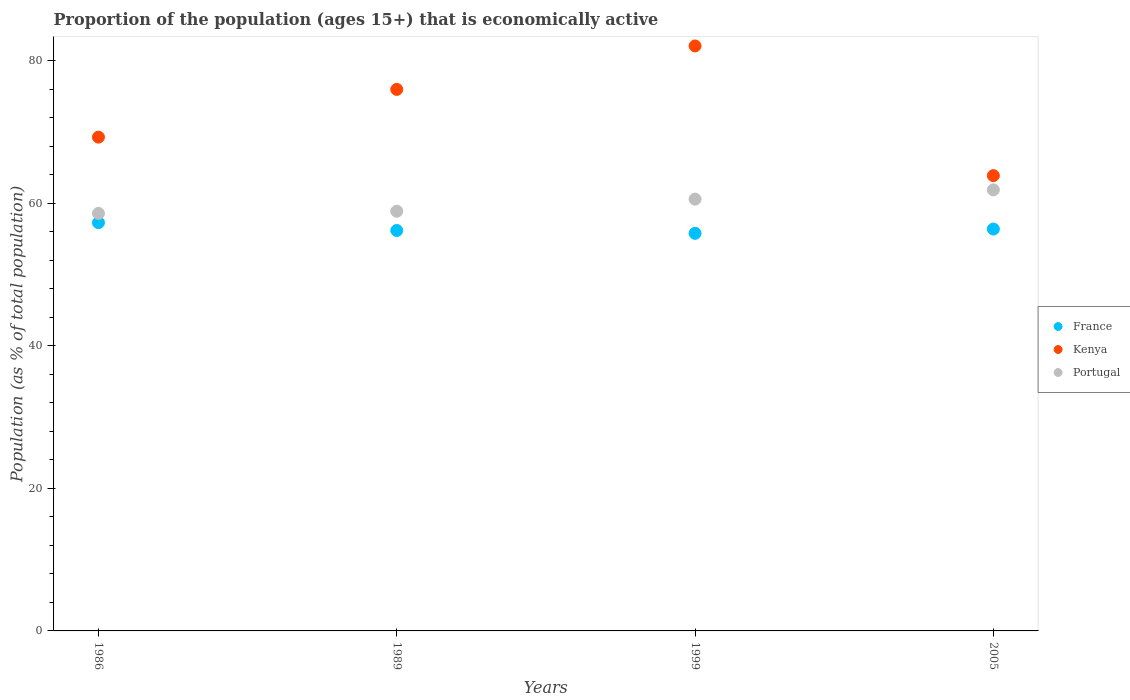Is the number of dotlines equal to the number of legend labels?
Make the answer very short. Yes. What is the proportion of the population that is economically active in Portugal in 1989?
Provide a succinct answer. 58.9. Across all years, what is the maximum proportion of the population that is economically active in Kenya?
Your response must be concise. 82.1. Across all years, what is the minimum proportion of the population that is economically active in France?
Make the answer very short. 55.8. In which year was the proportion of the population that is economically active in Kenya minimum?
Give a very brief answer. 2005. What is the total proportion of the population that is economically active in Portugal in the graph?
Keep it short and to the point. 240. What is the difference between the proportion of the population that is economically active in Kenya in 1986 and that in 2005?
Provide a short and direct response. 5.4. What is the difference between the proportion of the population that is economically active in Kenya in 1989 and the proportion of the population that is economically active in Portugal in 1986?
Provide a short and direct response. 17.4. What is the average proportion of the population that is economically active in France per year?
Offer a terse response. 56.43. In the year 1989, what is the difference between the proportion of the population that is economically active in Portugal and proportion of the population that is economically active in Kenya?
Offer a very short reply. -17.1. What is the ratio of the proportion of the population that is economically active in Portugal in 1989 to that in 2005?
Offer a very short reply. 0.95. Is the difference between the proportion of the population that is economically active in Portugal in 1989 and 1999 greater than the difference between the proportion of the population that is economically active in Kenya in 1989 and 1999?
Your answer should be compact. Yes. What is the difference between the highest and the second highest proportion of the population that is economically active in Kenya?
Provide a short and direct response. 6.1. What is the difference between the highest and the lowest proportion of the population that is economically active in France?
Provide a succinct answer. 1.5. In how many years, is the proportion of the population that is economically active in Portugal greater than the average proportion of the population that is economically active in Portugal taken over all years?
Make the answer very short. 2. Is it the case that in every year, the sum of the proportion of the population that is economically active in France and proportion of the population that is economically active in Portugal  is greater than the proportion of the population that is economically active in Kenya?
Your answer should be compact. Yes. Does the proportion of the population that is economically active in Kenya monotonically increase over the years?
Offer a very short reply. No. Is the proportion of the population that is economically active in Kenya strictly less than the proportion of the population that is economically active in France over the years?
Provide a short and direct response. No. How many dotlines are there?
Give a very brief answer. 3. What is the difference between two consecutive major ticks on the Y-axis?
Keep it short and to the point. 20. Does the graph contain grids?
Your response must be concise. No. What is the title of the graph?
Offer a very short reply. Proportion of the population (ages 15+) that is economically active. What is the label or title of the X-axis?
Your answer should be compact. Years. What is the label or title of the Y-axis?
Your response must be concise. Population (as % of total population). What is the Population (as % of total population) in France in 1986?
Ensure brevity in your answer.  57.3. What is the Population (as % of total population) of Kenya in 1986?
Offer a very short reply. 69.3. What is the Population (as % of total population) in Portugal in 1986?
Your response must be concise. 58.6. What is the Population (as % of total population) in France in 1989?
Provide a succinct answer. 56.2. What is the Population (as % of total population) in Kenya in 1989?
Offer a terse response. 76. What is the Population (as % of total population) of Portugal in 1989?
Your answer should be compact. 58.9. What is the Population (as % of total population) of France in 1999?
Make the answer very short. 55.8. What is the Population (as % of total population) in Kenya in 1999?
Make the answer very short. 82.1. What is the Population (as % of total population) in Portugal in 1999?
Provide a short and direct response. 60.6. What is the Population (as % of total population) of France in 2005?
Your answer should be compact. 56.4. What is the Population (as % of total population) of Kenya in 2005?
Provide a short and direct response. 63.9. What is the Population (as % of total population) of Portugal in 2005?
Offer a very short reply. 61.9. Across all years, what is the maximum Population (as % of total population) in France?
Ensure brevity in your answer.  57.3. Across all years, what is the maximum Population (as % of total population) in Kenya?
Provide a short and direct response. 82.1. Across all years, what is the maximum Population (as % of total population) of Portugal?
Make the answer very short. 61.9. Across all years, what is the minimum Population (as % of total population) in France?
Your response must be concise. 55.8. Across all years, what is the minimum Population (as % of total population) in Kenya?
Offer a very short reply. 63.9. Across all years, what is the minimum Population (as % of total population) in Portugal?
Your answer should be compact. 58.6. What is the total Population (as % of total population) of France in the graph?
Your answer should be very brief. 225.7. What is the total Population (as % of total population) of Kenya in the graph?
Your response must be concise. 291.3. What is the total Population (as % of total population) in Portugal in the graph?
Your answer should be very brief. 240. What is the difference between the Population (as % of total population) in France in 1986 and that in 1989?
Offer a terse response. 1.1. What is the difference between the Population (as % of total population) of Kenya in 1986 and that in 1989?
Give a very brief answer. -6.7. What is the difference between the Population (as % of total population) in Portugal in 1986 and that in 1989?
Your answer should be very brief. -0.3. What is the difference between the Population (as % of total population) of Kenya in 1986 and that in 1999?
Make the answer very short. -12.8. What is the difference between the Population (as % of total population) in Portugal in 1986 and that in 1999?
Make the answer very short. -2. What is the difference between the Population (as % of total population) of France in 1986 and that in 2005?
Provide a short and direct response. 0.9. What is the difference between the Population (as % of total population) of Portugal in 1989 and that in 1999?
Ensure brevity in your answer.  -1.7. What is the difference between the Population (as % of total population) in France in 1989 and that in 2005?
Ensure brevity in your answer.  -0.2. What is the difference between the Population (as % of total population) of Portugal in 1989 and that in 2005?
Your answer should be compact. -3. What is the difference between the Population (as % of total population) in Portugal in 1999 and that in 2005?
Your answer should be very brief. -1.3. What is the difference between the Population (as % of total population) in France in 1986 and the Population (as % of total population) in Kenya in 1989?
Offer a terse response. -18.7. What is the difference between the Population (as % of total population) of France in 1986 and the Population (as % of total population) of Portugal in 1989?
Give a very brief answer. -1.6. What is the difference between the Population (as % of total population) of France in 1986 and the Population (as % of total population) of Kenya in 1999?
Give a very brief answer. -24.8. What is the difference between the Population (as % of total population) of France in 1986 and the Population (as % of total population) of Portugal in 1999?
Your answer should be very brief. -3.3. What is the difference between the Population (as % of total population) of Kenya in 1986 and the Population (as % of total population) of Portugal in 1999?
Make the answer very short. 8.7. What is the difference between the Population (as % of total population) in France in 1989 and the Population (as % of total population) in Kenya in 1999?
Offer a terse response. -25.9. What is the difference between the Population (as % of total population) in Kenya in 1989 and the Population (as % of total population) in Portugal in 1999?
Offer a terse response. 15.4. What is the difference between the Population (as % of total population) in France in 1989 and the Population (as % of total population) in Kenya in 2005?
Your answer should be very brief. -7.7. What is the difference between the Population (as % of total population) of France in 1989 and the Population (as % of total population) of Portugal in 2005?
Provide a short and direct response. -5.7. What is the difference between the Population (as % of total population) of France in 1999 and the Population (as % of total population) of Kenya in 2005?
Make the answer very short. -8.1. What is the difference between the Population (as % of total population) of France in 1999 and the Population (as % of total population) of Portugal in 2005?
Offer a terse response. -6.1. What is the difference between the Population (as % of total population) in Kenya in 1999 and the Population (as % of total population) in Portugal in 2005?
Make the answer very short. 20.2. What is the average Population (as % of total population) in France per year?
Make the answer very short. 56.42. What is the average Population (as % of total population) of Kenya per year?
Keep it short and to the point. 72.83. In the year 1986, what is the difference between the Population (as % of total population) in France and Population (as % of total population) in Kenya?
Your answer should be compact. -12. In the year 1986, what is the difference between the Population (as % of total population) in France and Population (as % of total population) in Portugal?
Your response must be concise. -1.3. In the year 1986, what is the difference between the Population (as % of total population) in Kenya and Population (as % of total population) in Portugal?
Keep it short and to the point. 10.7. In the year 1989, what is the difference between the Population (as % of total population) in France and Population (as % of total population) in Kenya?
Provide a short and direct response. -19.8. In the year 1999, what is the difference between the Population (as % of total population) in France and Population (as % of total population) in Kenya?
Ensure brevity in your answer.  -26.3. In the year 1999, what is the difference between the Population (as % of total population) of France and Population (as % of total population) of Portugal?
Your answer should be compact. -4.8. In the year 2005, what is the difference between the Population (as % of total population) of France and Population (as % of total population) of Kenya?
Offer a terse response. -7.5. What is the ratio of the Population (as % of total population) of France in 1986 to that in 1989?
Your answer should be compact. 1.02. What is the ratio of the Population (as % of total population) of Kenya in 1986 to that in 1989?
Make the answer very short. 0.91. What is the ratio of the Population (as % of total population) of France in 1986 to that in 1999?
Your response must be concise. 1.03. What is the ratio of the Population (as % of total population) in Kenya in 1986 to that in 1999?
Provide a short and direct response. 0.84. What is the ratio of the Population (as % of total population) in Kenya in 1986 to that in 2005?
Provide a short and direct response. 1.08. What is the ratio of the Population (as % of total population) in Portugal in 1986 to that in 2005?
Ensure brevity in your answer.  0.95. What is the ratio of the Population (as % of total population) of Kenya in 1989 to that in 1999?
Your answer should be very brief. 0.93. What is the ratio of the Population (as % of total population) in Portugal in 1989 to that in 1999?
Offer a very short reply. 0.97. What is the ratio of the Population (as % of total population) in France in 1989 to that in 2005?
Your answer should be very brief. 1. What is the ratio of the Population (as % of total population) of Kenya in 1989 to that in 2005?
Offer a terse response. 1.19. What is the ratio of the Population (as % of total population) of Portugal in 1989 to that in 2005?
Ensure brevity in your answer.  0.95. What is the ratio of the Population (as % of total population) in France in 1999 to that in 2005?
Your response must be concise. 0.99. What is the ratio of the Population (as % of total population) in Kenya in 1999 to that in 2005?
Make the answer very short. 1.28. What is the difference between the highest and the second highest Population (as % of total population) in France?
Offer a very short reply. 0.9. What is the difference between the highest and the second highest Population (as % of total population) of Portugal?
Offer a terse response. 1.3. What is the difference between the highest and the lowest Population (as % of total population) in France?
Keep it short and to the point. 1.5. What is the difference between the highest and the lowest Population (as % of total population) of Kenya?
Provide a succinct answer. 18.2. 